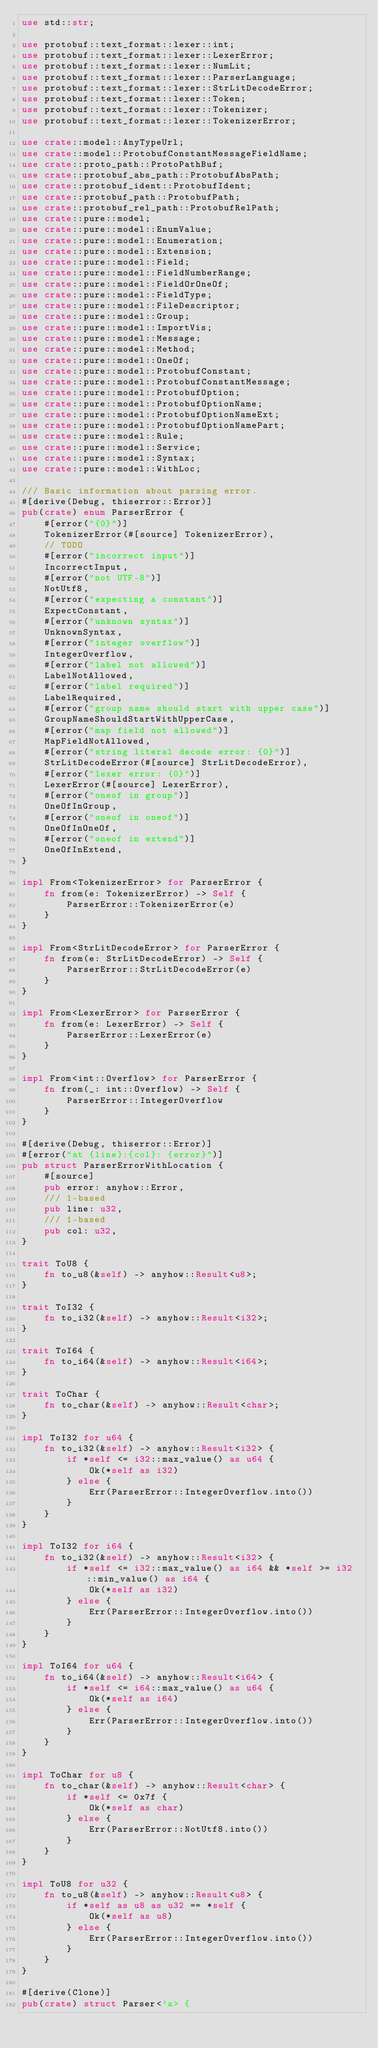Convert code to text. <code><loc_0><loc_0><loc_500><loc_500><_Rust_>use std::str;

use protobuf::text_format::lexer::int;
use protobuf::text_format::lexer::LexerError;
use protobuf::text_format::lexer::NumLit;
use protobuf::text_format::lexer::ParserLanguage;
use protobuf::text_format::lexer::StrLitDecodeError;
use protobuf::text_format::lexer::Token;
use protobuf::text_format::lexer::Tokenizer;
use protobuf::text_format::lexer::TokenizerError;

use crate::model::AnyTypeUrl;
use crate::model::ProtobufConstantMessageFieldName;
use crate::proto_path::ProtoPathBuf;
use crate::protobuf_abs_path::ProtobufAbsPath;
use crate::protobuf_ident::ProtobufIdent;
use crate::protobuf_path::ProtobufPath;
use crate::protobuf_rel_path::ProtobufRelPath;
use crate::pure::model;
use crate::pure::model::EnumValue;
use crate::pure::model::Enumeration;
use crate::pure::model::Extension;
use crate::pure::model::Field;
use crate::pure::model::FieldNumberRange;
use crate::pure::model::FieldOrOneOf;
use crate::pure::model::FieldType;
use crate::pure::model::FileDescriptor;
use crate::pure::model::Group;
use crate::pure::model::ImportVis;
use crate::pure::model::Message;
use crate::pure::model::Method;
use crate::pure::model::OneOf;
use crate::pure::model::ProtobufConstant;
use crate::pure::model::ProtobufConstantMessage;
use crate::pure::model::ProtobufOption;
use crate::pure::model::ProtobufOptionName;
use crate::pure::model::ProtobufOptionNameExt;
use crate::pure::model::ProtobufOptionNamePart;
use crate::pure::model::Rule;
use crate::pure::model::Service;
use crate::pure::model::Syntax;
use crate::pure::model::WithLoc;

/// Basic information about parsing error.
#[derive(Debug, thiserror::Error)]
pub(crate) enum ParserError {
    #[error("{0}")]
    TokenizerError(#[source] TokenizerError),
    // TODO
    #[error("incorrect input")]
    IncorrectInput,
    #[error("not UTF-8")]
    NotUtf8,
    #[error("expecting a constant")]
    ExpectConstant,
    #[error("unknown syntax")]
    UnknownSyntax,
    #[error("integer overflow")]
    IntegerOverflow,
    #[error("label not allowed")]
    LabelNotAllowed,
    #[error("label required")]
    LabelRequired,
    #[error("group name should start with upper case")]
    GroupNameShouldStartWithUpperCase,
    #[error("map field not allowed")]
    MapFieldNotAllowed,
    #[error("string literal decode error: {0}")]
    StrLitDecodeError(#[source] StrLitDecodeError),
    #[error("lexer error: {0}")]
    LexerError(#[source] LexerError),
    #[error("oneof in group")]
    OneOfInGroup,
    #[error("oneof in oneof")]
    OneOfInOneOf,
    #[error("oneof in extend")]
    OneOfInExtend,
}

impl From<TokenizerError> for ParserError {
    fn from(e: TokenizerError) -> Self {
        ParserError::TokenizerError(e)
    }
}

impl From<StrLitDecodeError> for ParserError {
    fn from(e: StrLitDecodeError) -> Self {
        ParserError::StrLitDecodeError(e)
    }
}

impl From<LexerError> for ParserError {
    fn from(e: LexerError) -> Self {
        ParserError::LexerError(e)
    }
}

impl From<int::Overflow> for ParserError {
    fn from(_: int::Overflow) -> Self {
        ParserError::IntegerOverflow
    }
}

#[derive(Debug, thiserror::Error)]
#[error("at {line}:{col}: {error}")]
pub struct ParserErrorWithLocation {
    #[source]
    pub error: anyhow::Error,
    /// 1-based
    pub line: u32,
    /// 1-based
    pub col: u32,
}

trait ToU8 {
    fn to_u8(&self) -> anyhow::Result<u8>;
}

trait ToI32 {
    fn to_i32(&self) -> anyhow::Result<i32>;
}

trait ToI64 {
    fn to_i64(&self) -> anyhow::Result<i64>;
}

trait ToChar {
    fn to_char(&self) -> anyhow::Result<char>;
}

impl ToI32 for u64 {
    fn to_i32(&self) -> anyhow::Result<i32> {
        if *self <= i32::max_value() as u64 {
            Ok(*self as i32)
        } else {
            Err(ParserError::IntegerOverflow.into())
        }
    }
}

impl ToI32 for i64 {
    fn to_i32(&self) -> anyhow::Result<i32> {
        if *self <= i32::max_value() as i64 && *self >= i32::min_value() as i64 {
            Ok(*self as i32)
        } else {
            Err(ParserError::IntegerOverflow.into())
        }
    }
}

impl ToI64 for u64 {
    fn to_i64(&self) -> anyhow::Result<i64> {
        if *self <= i64::max_value() as u64 {
            Ok(*self as i64)
        } else {
            Err(ParserError::IntegerOverflow.into())
        }
    }
}

impl ToChar for u8 {
    fn to_char(&self) -> anyhow::Result<char> {
        if *self <= 0x7f {
            Ok(*self as char)
        } else {
            Err(ParserError::NotUtf8.into())
        }
    }
}

impl ToU8 for u32 {
    fn to_u8(&self) -> anyhow::Result<u8> {
        if *self as u8 as u32 == *self {
            Ok(*self as u8)
        } else {
            Err(ParserError::IntegerOverflow.into())
        }
    }
}

#[derive(Clone)]
pub(crate) struct Parser<'a> {</code> 